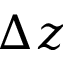<formula> <loc_0><loc_0><loc_500><loc_500>\Delta z</formula> 